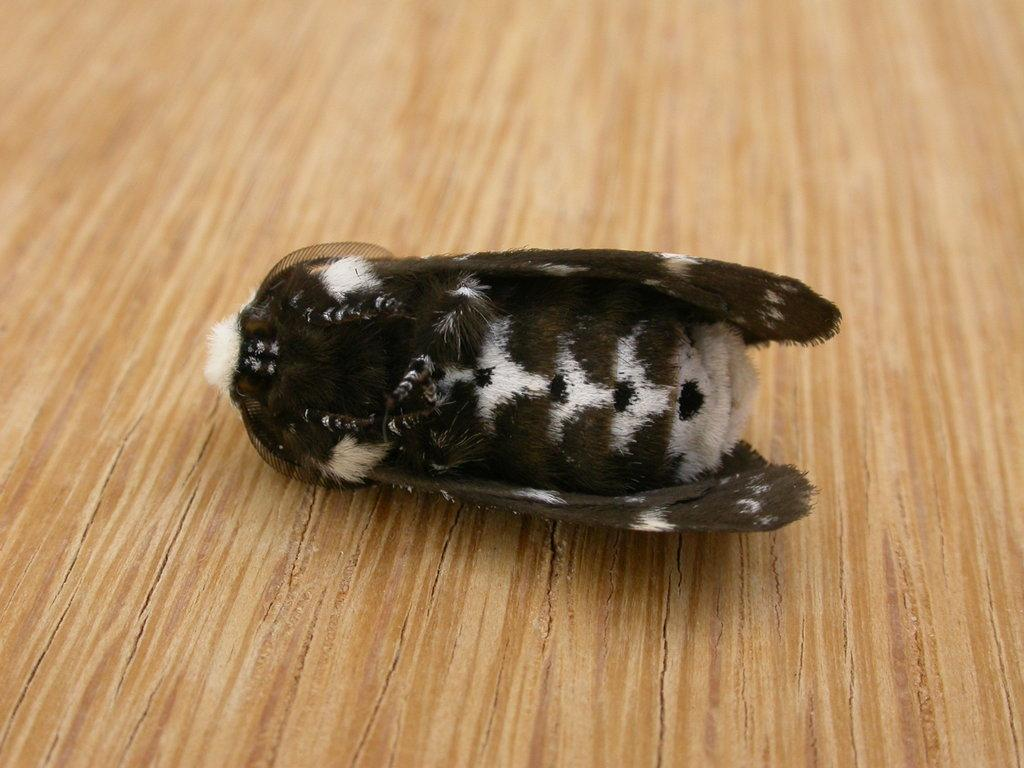What is present on the wooden surface in the image? There is an insect on the wooden surface in the image. Can you describe the wooden surface in the image? The wooden surface is the background on which the insect is present. What type of acoustics can be heard from the insect in the image? There is no sound or acoustics associated with the insect in the image, as it is a still image. 